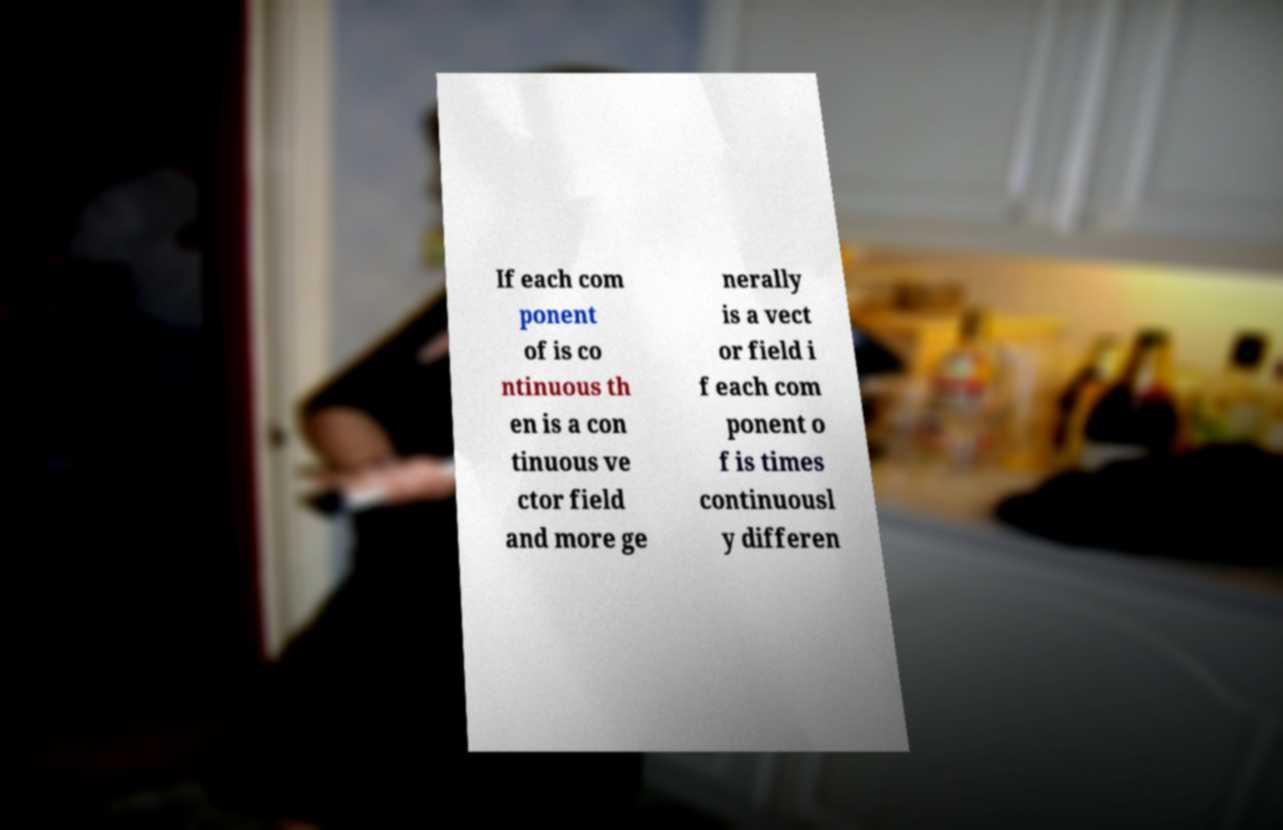Please read and relay the text visible in this image. What does it say? If each com ponent of is co ntinuous th en is a con tinuous ve ctor field and more ge nerally is a vect or field i f each com ponent o f is times continuousl y differen 